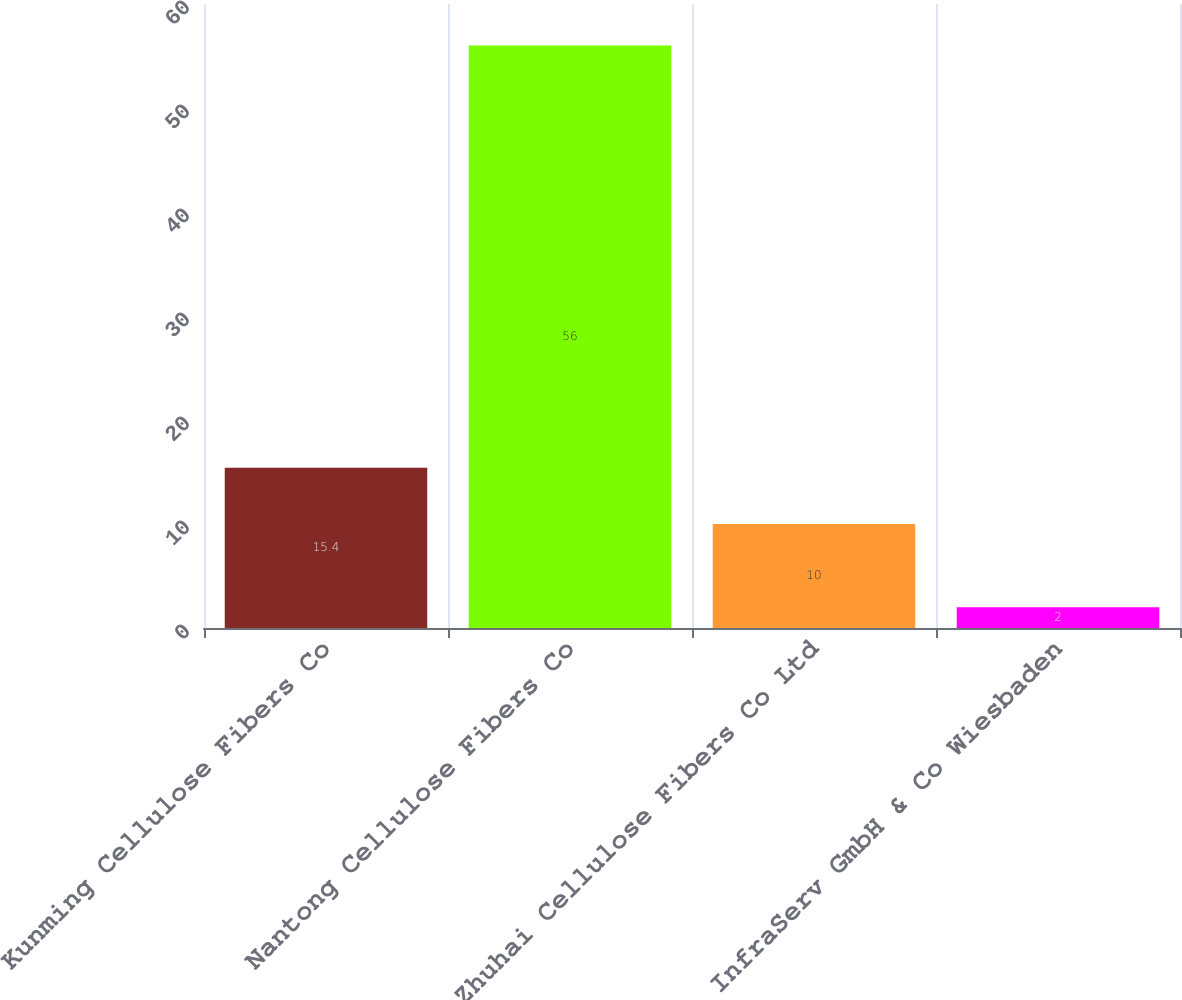<chart> <loc_0><loc_0><loc_500><loc_500><bar_chart><fcel>Kunming Cellulose Fibers Co<fcel>Nantong Cellulose Fibers Co<fcel>Zhuhai Cellulose Fibers Co Ltd<fcel>InfraServ GmbH & Co Wiesbaden<nl><fcel>15.4<fcel>56<fcel>10<fcel>2<nl></chart> 